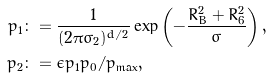Convert formula to latex. <formula><loc_0><loc_0><loc_500><loc_500>p _ { 1 } & \colon = \frac { 1 } { ( 2 \pi \sigma _ { 2 } ) ^ { d / 2 } } \exp \left ( - \frac { R _ { B } ^ { 2 } + R _ { 6 } ^ { 2 } } { \sigma } \right ) , \\ p _ { 2 } & \colon = \epsilon p _ { 1 } p _ { 0 } / p _ { \max } ,</formula> 